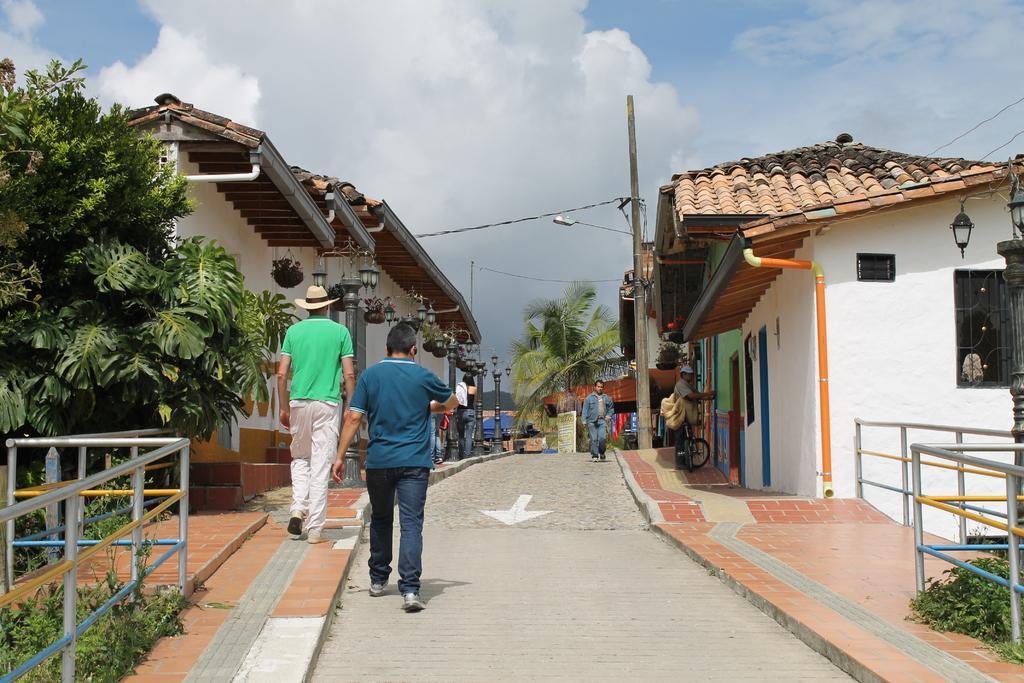Please provide a concise description of this image. In this picture we can see few metal rods, trees, houses and poles, and also we can find group of people, in the background we can see clouds, on the right side of the image we can find few lights. 